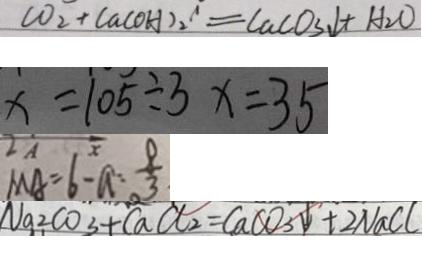Convert formula to latex. <formula><loc_0><loc_0><loc_500><loc_500>C O _ { 2 } + C a ( O H ) _ { 2 } ^ { \prime } = C a C O _ { 3 } \downarrow + H _ { 2 } O 
 x = 1 0 5 \div 3 x = 3 5 
 M A = 6 - a : \frac { 8 } { 3 } 
 N a _ { 2 } C O _ { 3 } + C a C l _ { 2 } = C a C O _ { 3 } \downarrow + 2 N a C l</formula> 